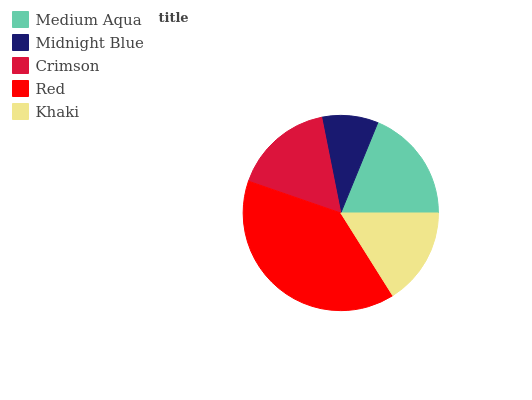Is Midnight Blue the minimum?
Answer yes or no. Yes. Is Red the maximum?
Answer yes or no. Yes. Is Crimson the minimum?
Answer yes or no. No. Is Crimson the maximum?
Answer yes or no. No. Is Crimson greater than Midnight Blue?
Answer yes or no. Yes. Is Midnight Blue less than Crimson?
Answer yes or no. Yes. Is Midnight Blue greater than Crimson?
Answer yes or no. No. Is Crimson less than Midnight Blue?
Answer yes or no. No. Is Crimson the high median?
Answer yes or no. Yes. Is Crimson the low median?
Answer yes or no. Yes. Is Red the high median?
Answer yes or no. No. Is Khaki the low median?
Answer yes or no. No. 